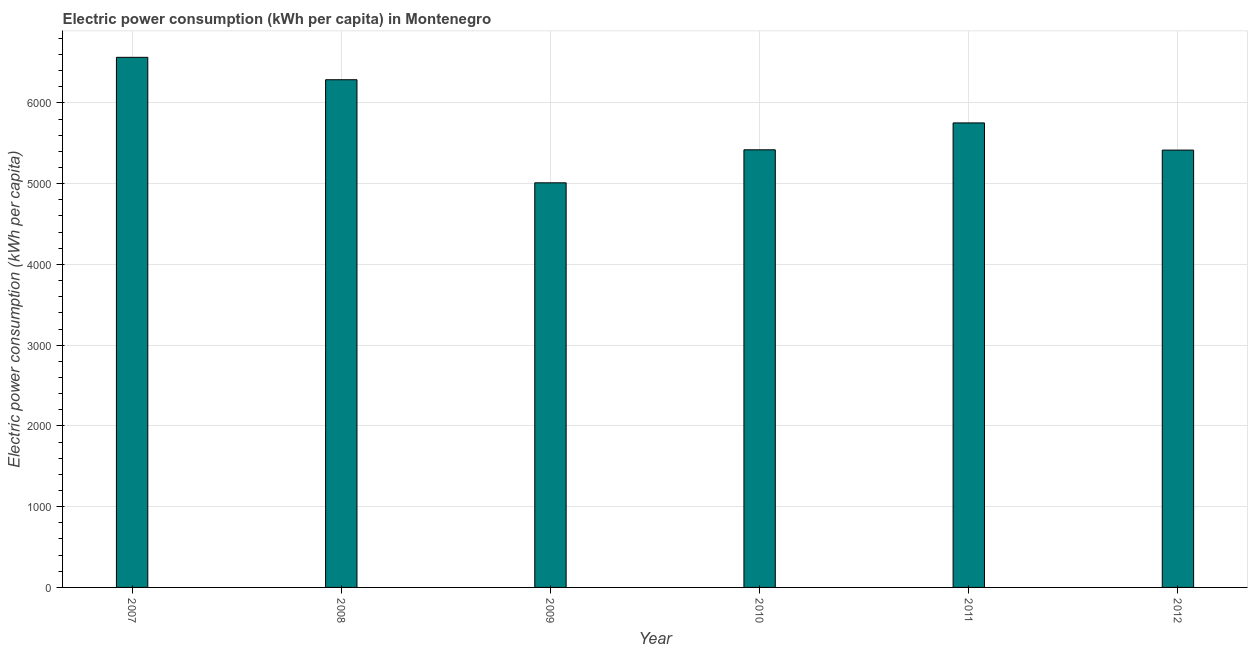Does the graph contain any zero values?
Give a very brief answer. No. What is the title of the graph?
Make the answer very short. Electric power consumption (kWh per capita) in Montenegro. What is the label or title of the Y-axis?
Offer a very short reply. Electric power consumption (kWh per capita). What is the electric power consumption in 2010?
Give a very brief answer. 5419.52. Across all years, what is the maximum electric power consumption?
Give a very brief answer. 6564.64. Across all years, what is the minimum electric power consumption?
Offer a very short reply. 5010.56. What is the sum of the electric power consumption?
Provide a short and direct response. 3.45e+04. What is the difference between the electric power consumption in 2009 and 2010?
Offer a terse response. -408.95. What is the average electric power consumption per year?
Your response must be concise. 5741.69. What is the median electric power consumption?
Ensure brevity in your answer.  5586. In how many years, is the electric power consumption greater than 3400 kWh per capita?
Offer a terse response. 6. Do a majority of the years between 2011 and 2007 (inclusive) have electric power consumption greater than 2000 kWh per capita?
Keep it short and to the point. Yes. What is the ratio of the electric power consumption in 2007 to that in 2008?
Provide a short and direct response. 1.04. Is the electric power consumption in 2009 less than that in 2011?
Keep it short and to the point. Yes. Is the difference between the electric power consumption in 2007 and 2011 greater than the difference between any two years?
Offer a very short reply. No. What is the difference between the highest and the second highest electric power consumption?
Make the answer very short. 277.46. Is the sum of the electric power consumption in 2007 and 2011 greater than the maximum electric power consumption across all years?
Provide a short and direct response. Yes. What is the difference between the highest and the lowest electric power consumption?
Your response must be concise. 1554.08. How many bars are there?
Your response must be concise. 6. What is the difference between two consecutive major ticks on the Y-axis?
Your response must be concise. 1000. What is the Electric power consumption (kWh per capita) of 2007?
Offer a terse response. 6564.64. What is the Electric power consumption (kWh per capita) of 2008?
Your response must be concise. 6287.19. What is the Electric power consumption (kWh per capita) of 2009?
Your response must be concise. 5010.56. What is the Electric power consumption (kWh per capita) in 2010?
Offer a very short reply. 5419.52. What is the Electric power consumption (kWh per capita) of 2011?
Ensure brevity in your answer.  5752.49. What is the Electric power consumption (kWh per capita) in 2012?
Your response must be concise. 5415.72. What is the difference between the Electric power consumption (kWh per capita) in 2007 and 2008?
Keep it short and to the point. 277.46. What is the difference between the Electric power consumption (kWh per capita) in 2007 and 2009?
Ensure brevity in your answer.  1554.08. What is the difference between the Electric power consumption (kWh per capita) in 2007 and 2010?
Provide a succinct answer. 1145.13. What is the difference between the Electric power consumption (kWh per capita) in 2007 and 2011?
Your response must be concise. 812.15. What is the difference between the Electric power consumption (kWh per capita) in 2007 and 2012?
Keep it short and to the point. 1148.93. What is the difference between the Electric power consumption (kWh per capita) in 2008 and 2009?
Offer a very short reply. 1276.63. What is the difference between the Electric power consumption (kWh per capita) in 2008 and 2010?
Make the answer very short. 867.67. What is the difference between the Electric power consumption (kWh per capita) in 2008 and 2011?
Offer a terse response. 534.7. What is the difference between the Electric power consumption (kWh per capita) in 2008 and 2012?
Your answer should be compact. 871.47. What is the difference between the Electric power consumption (kWh per capita) in 2009 and 2010?
Keep it short and to the point. -408.95. What is the difference between the Electric power consumption (kWh per capita) in 2009 and 2011?
Your answer should be compact. -741.93. What is the difference between the Electric power consumption (kWh per capita) in 2009 and 2012?
Provide a short and direct response. -405.16. What is the difference between the Electric power consumption (kWh per capita) in 2010 and 2011?
Your response must be concise. -332.98. What is the difference between the Electric power consumption (kWh per capita) in 2010 and 2012?
Your response must be concise. 3.8. What is the difference between the Electric power consumption (kWh per capita) in 2011 and 2012?
Make the answer very short. 336.77. What is the ratio of the Electric power consumption (kWh per capita) in 2007 to that in 2008?
Ensure brevity in your answer.  1.04. What is the ratio of the Electric power consumption (kWh per capita) in 2007 to that in 2009?
Give a very brief answer. 1.31. What is the ratio of the Electric power consumption (kWh per capita) in 2007 to that in 2010?
Keep it short and to the point. 1.21. What is the ratio of the Electric power consumption (kWh per capita) in 2007 to that in 2011?
Offer a very short reply. 1.14. What is the ratio of the Electric power consumption (kWh per capita) in 2007 to that in 2012?
Make the answer very short. 1.21. What is the ratio of the Electric power consumption (kWh per capita) in 2008 to that in 2009?
Your response must be concise. 1.25. What is the ratio of the Electric power consumption (kWh per capita) in 2008 to that in 2010?
Keep it short and to the point. 1.16. What is the ratio of the Electric power consumption (kWh per capita) in 2008 to that in 2011?
Your answer should be very brief. 1.09. What is the ratio of the Electric power consumption (kWh per capita) in 2008 to that in 2012?
Your answer should be compact. 1.16. What is the ratio of the Electric power consumption (kWh per capita) in 2009 to that in 2010?
Make the answer very short. 0.93. What is the ratio of the Electric power consumption (kWh per capita) in 2009 to that in 2011?
Provide a succinct answer. 0.87. What is the ratio of the Electric power consumption (kWh per capita) in 2009 to that in 2012?
Your response must be concise. 0.93. What is the ratio of the Electric power consumption (kWh per capita) in 2010 to that in 2011?
Your answer should be very brief. 0.94. What is the ratio of the Electric power consumption (kWh per capita) in 2010 to that in 2012?
Provide a succinct answer. 1. What is the ratio of the Electric power consumption (kWh per capita) in 2011 to that in 2012?
Ensure brevity in your answer.  1.06. 